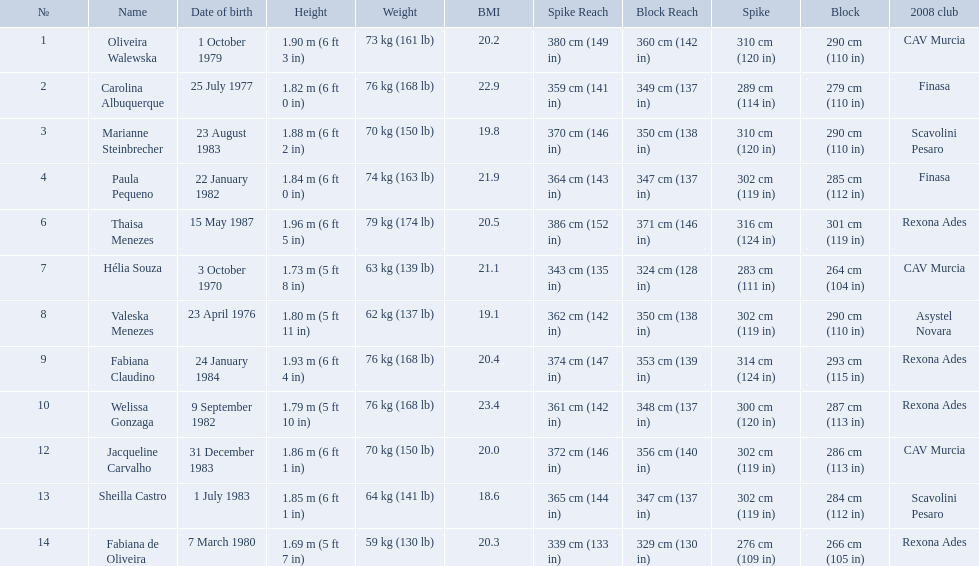How much does fabiana de oliveira weigh? 76 kg (168 lb). How much does helia souza weigh? 63 kg (139 lb). How much does sheilla castro weigh? 64 kg (141 lb). Whose weight did the original question asker incorrectly believe to be the heaviest (they are the second heaviest)? Sheilla Castro. What are the heights of the players? 1.90 m (6 ft 3 in), 1.82 m (6 ft 0 in), 1.88 m (6 ft 2 in), 1.84 m (6 ft 0 in), 1.96 m (6 ft 5 in), 1.73 m (5 ft 8 in), 1.80 m (5 ft 11 in), 1.93 m (6 ft 4 in), 1.79 m (5 ft 10 in), 1.86 m (6 ft 1 in), 1.85 m (6 ft 1 in), 1.69 m (5 ft 7 in). Which of these heights is the shortest? 1.69 m (5 ft 7 in). Which player is 5'7 tall? Fabiana de Oliveira. Who are the players for brazil at the 2008 summer olympics? Oliveira Walewska, Carolina Albuquerque, Marianne Steinbrecher, Paula Pequeno, Thaisa Menezes, Hélia Souza, Valeska Menezes, Fabiana Claudino, Welissa Gonzaga, Jacqueline Carvalho, Sheilla Castro, Fabiana de Oliveira. What are their heights? 1.90 m (6 ft 3 in), 1.82 m (6 ft 0 in), 1.88 m (6 ft 2 in), 1.84 m (6 ft 0 in), 1.96 m (6 ft 5 in), 1.73 m (5 ft 8 in), 1.80 m (5 ft 11 in), 1.93 m (6 ft 4 in), 1.79 m (5 ft 10 in), 1.86 m (6 ft 1 in), 1.85 m (6 ft 1 in), 1.69 m (5 ft 7 in). What is the shortest height? 1.69 m (5 ft 7 in). Which player is that? Fabiana de Oliveira. 